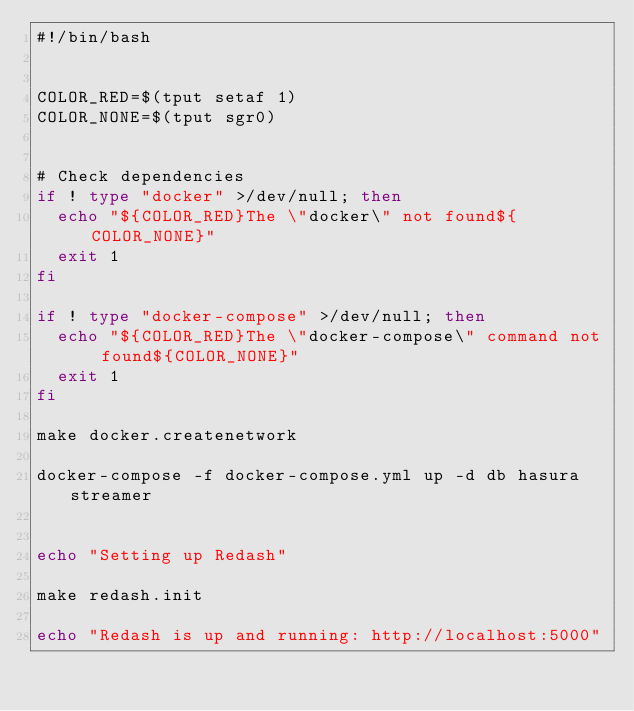<code> <loc_0><loc_0><loc_500><loc_500><_Bash_>#!/bin/bash


COLOR_RED=$(tput setaf 1)
COLOR_NONE=$(tput sgr0)


# Check dependencies
if ! type "docker" >/dev/null; then
  echo "${COLOR_RED}The \"docker\" not found${COLOR_NONE}"
  exit 1
fi

if ! type "docker-compose" >/dev/null; then
  echo "${COLOR_RED}The \"docker-compose\" command not found${COLOR_NONE}"
  exit 1
fi

make docker.createnetwork

docker-compose -f docker-compose.yml up -d db hasura streamer


echo "Setting up Redash"

make redash.init

echo "Redash is up and running: http://localhost:5000"
</code> 